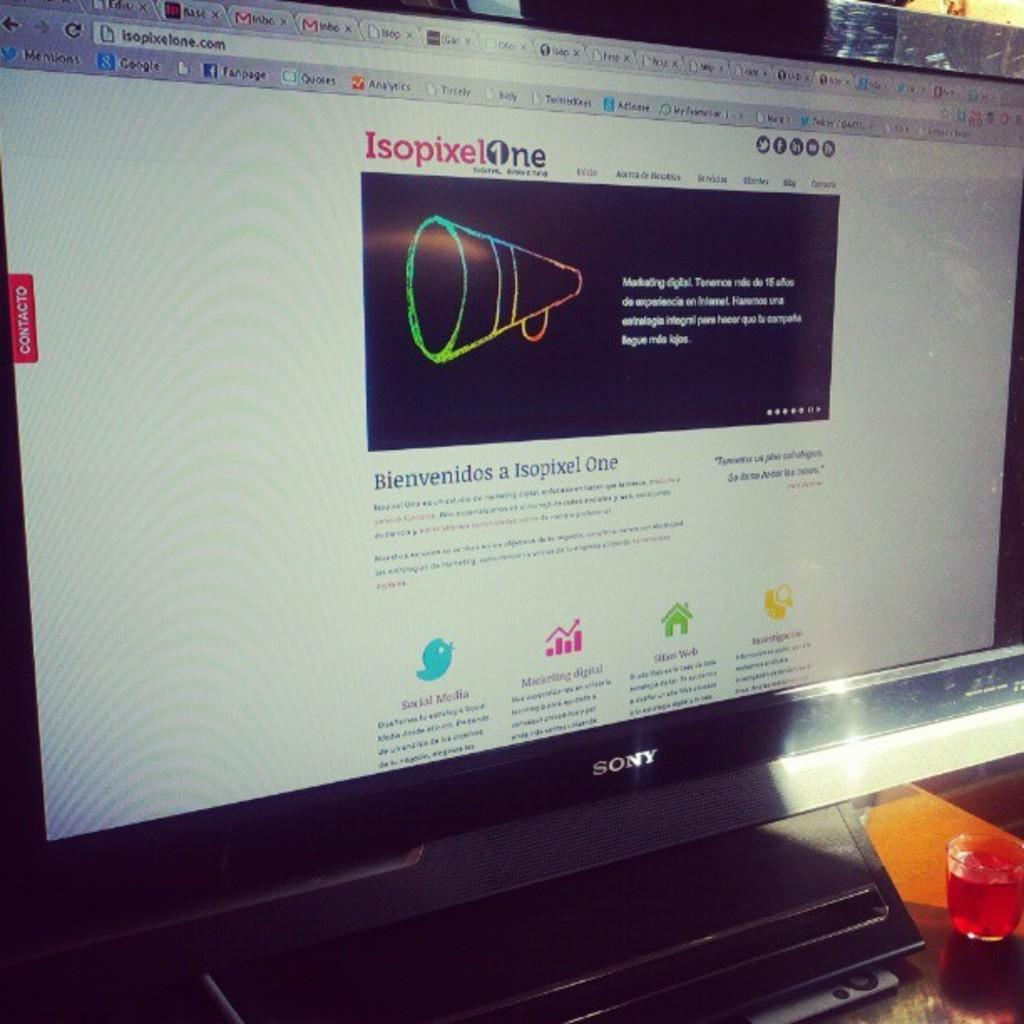<image>
Create a compact narrative representing the image presented. A monitor displays the home page of isopixelone.com. 